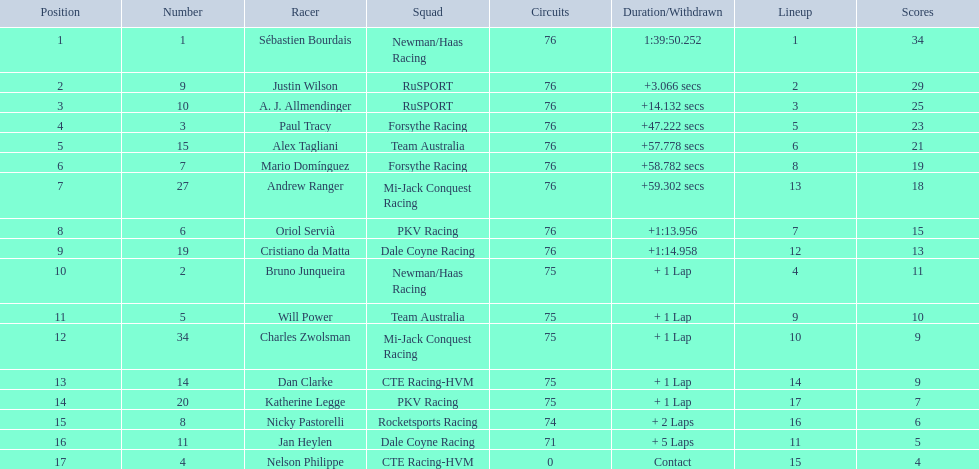Is there a driver named charles zwolsman? Charles Zwolsman. How many points did he acquire? 9. Were there any other entries that got the same number of points? 9. Who did that entry belong to? Dan Clarke. 